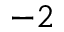Convert formula to latex. <formula><loc_0><loc_0><loc_500><loc_500>^ { - 2 }</formula> 